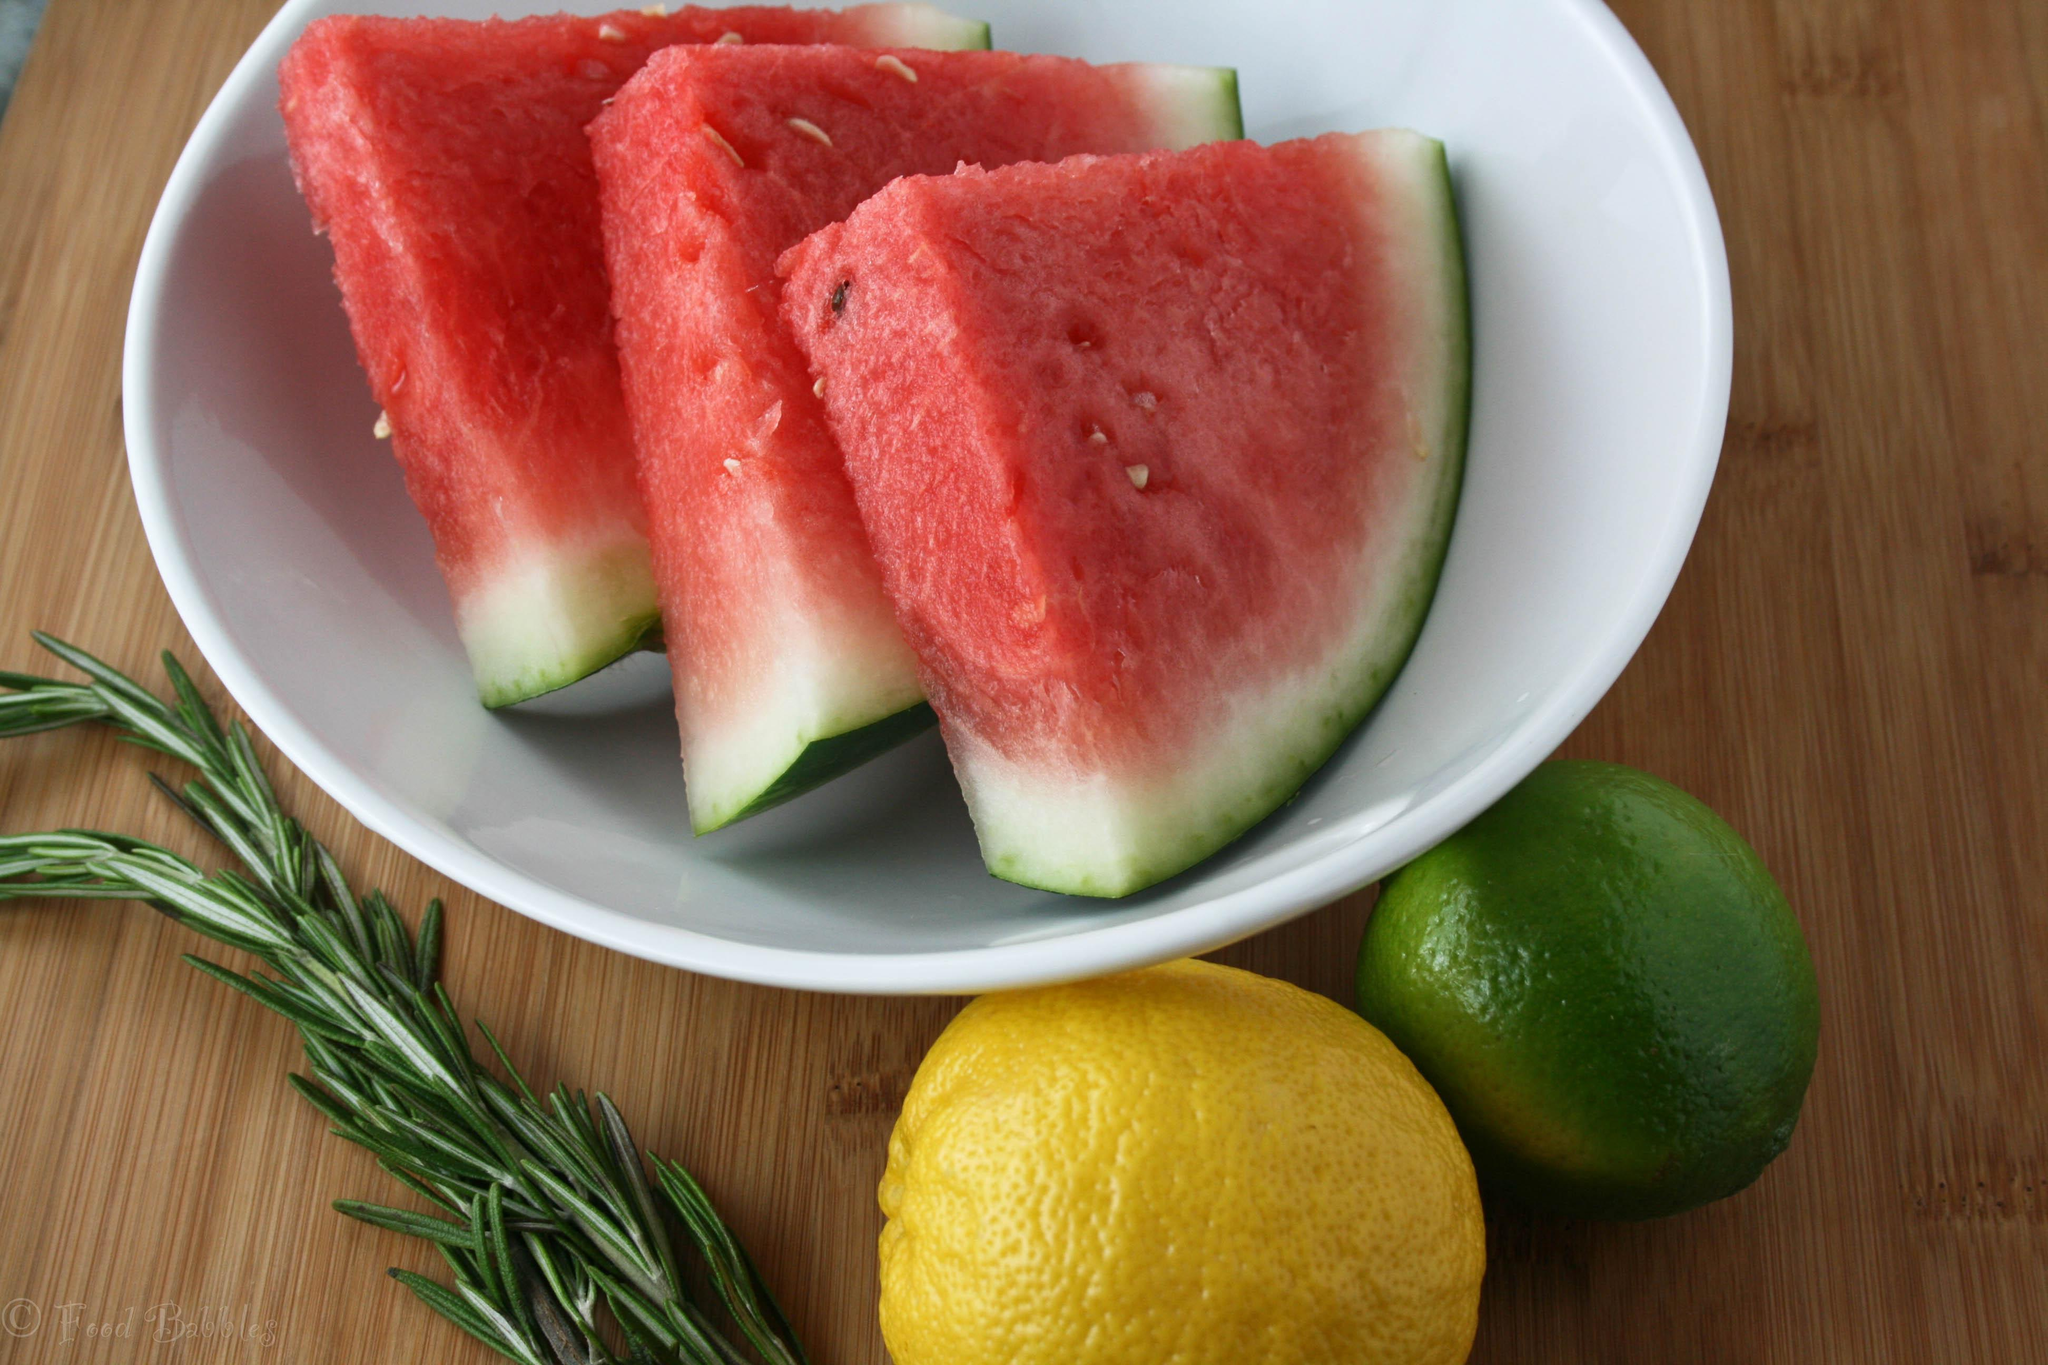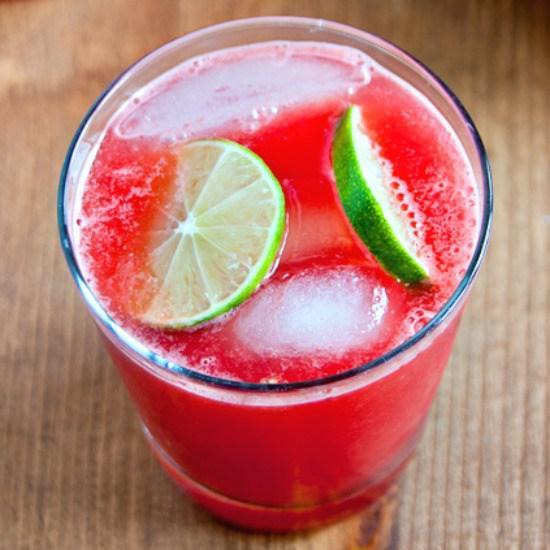The first image is the image on the left, the second image is the image on the right. For the images displayed, is the sentence "In one image, glasses are garnished with lemon pieces." factually correct? Answer yes or no. No. 